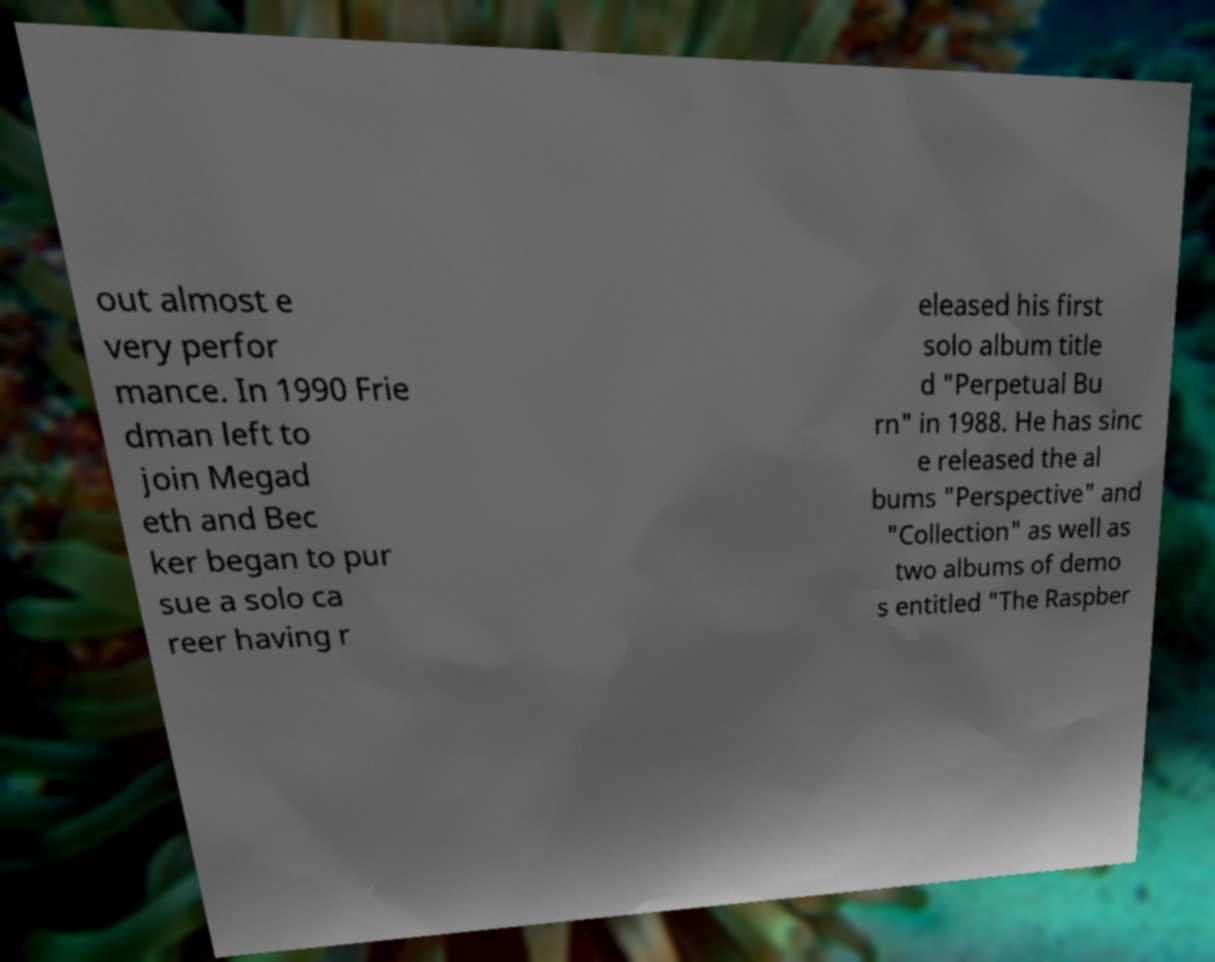Can you read and provide the text displayed in the image?This photo seems to have some interesting text. Can you extract and type it out for me? out almost e very perfor mance. In 1990 Frie dman left to join Megad eth and Bec ker began to pur sue a solo ca reer having r eleased his first solo album title d "Perpetual Bu rn" in 1988. He has sinc e released the al bums "Perspective" and "Collection" as well as two albums of demo s entitled "The Raspber 